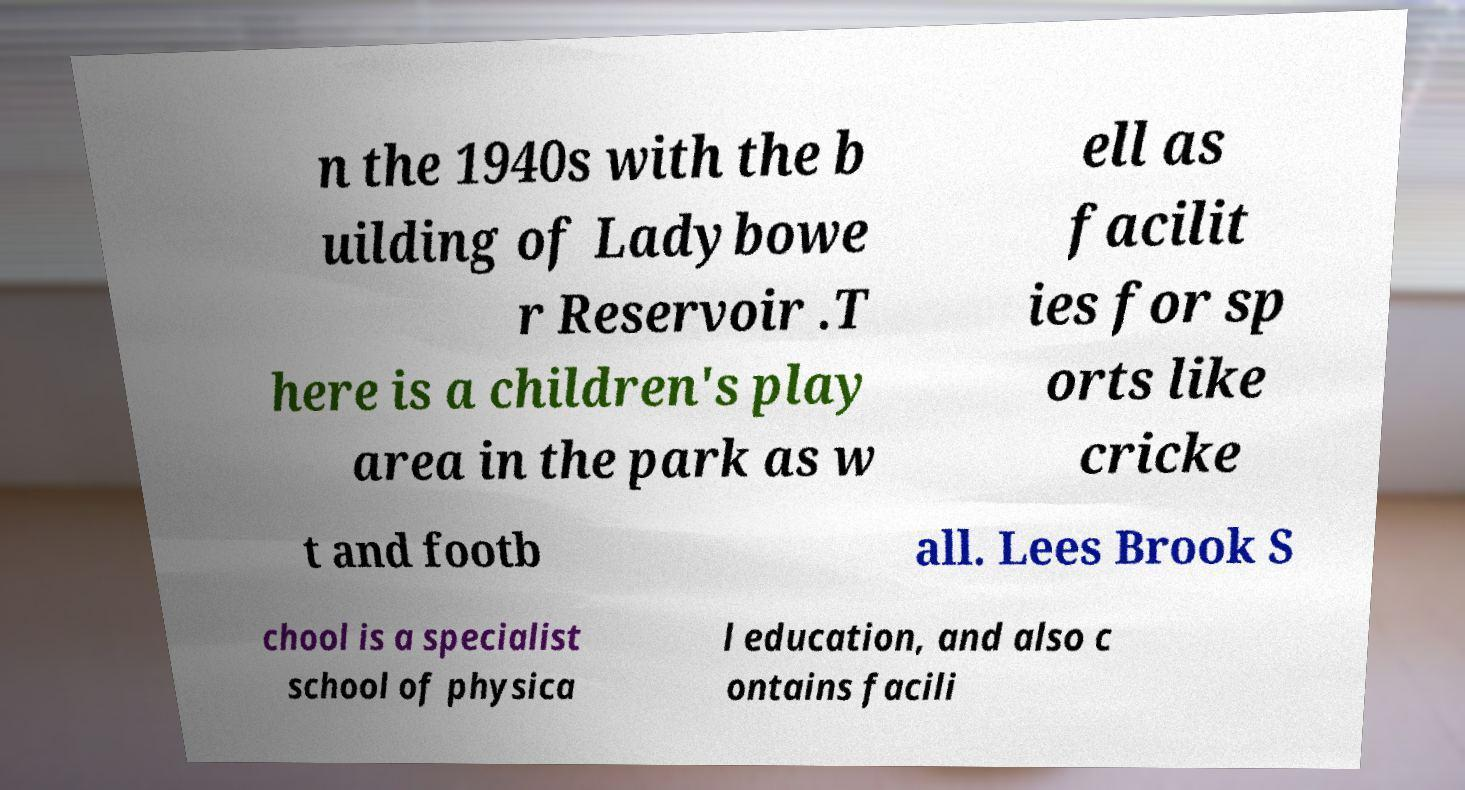There's text embedded in this image that I need extracted. Can you transcribe it verbatim? n the 1940s with the b uilding of Ladybowe r Reservoir .T here is a children's play area in the park as w ell as facilit ies for sp orts like cricke t and footb all. Lees Brook S chool is a specialist school of physica l education, and also c ontains facili 